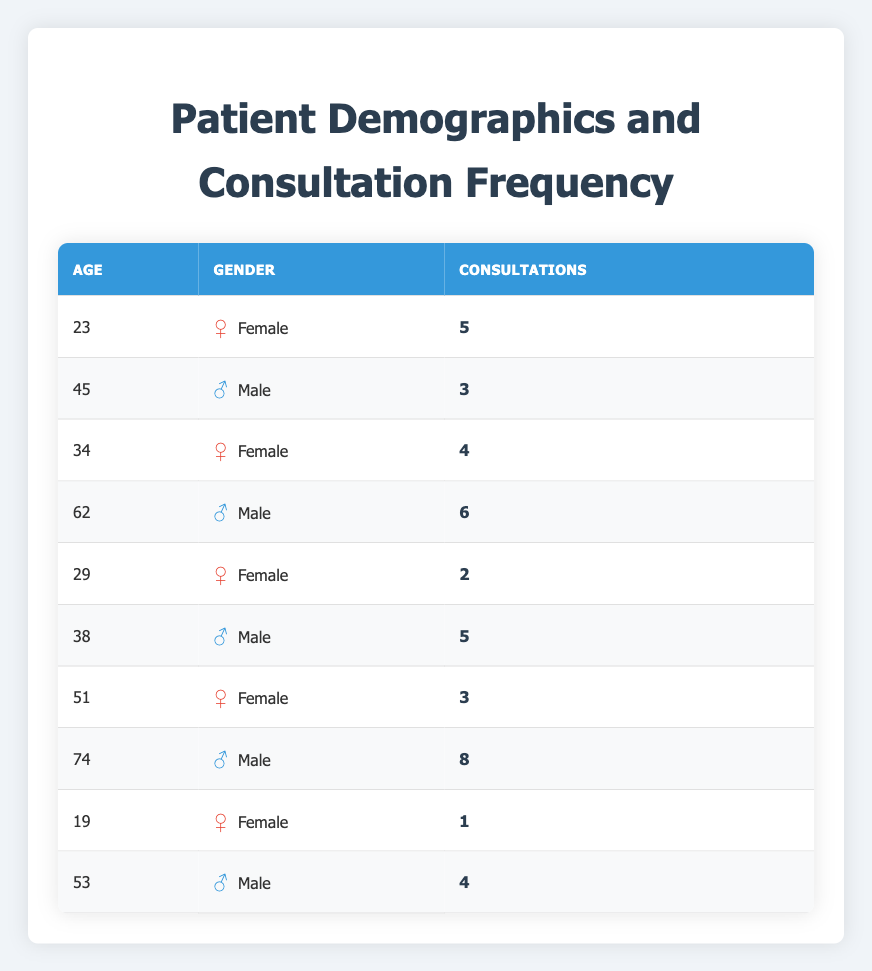What is the maximum number of consultations recorded for a patient? By reviewing the 'Consultations' column in the table, I can see that the highest value is 8, which corresponds to the patient aged 74.
Answer: 8 How many female patients have more than 3 consultations? I look at the 'Gender' column and filter for female patients. The only female patients with more than 3 consultations are aged 23 (5 consultations) and 34 (4 consultations). Therefore, there are 2 patients.
Answer: 2 What is the average age of male patients in the table? I identify the male patients in the table: 45, 62, 38, 74, and 53. I add their ages together (45 + 62 + 38 + 74 + 53) = 272. There are 5 male patients, so the average age is 272 / 5 = 54.4.
Answer: 54.4 Do all patients aged above 60 have a higher number of consultations than younger patients? The aged patients in the table above 60 are aged 62 (6 consultations) and 74 (8 consultations). The consultations of these patients are indeed higher than the patients aged 19 (1 consultation), 23 (5 consultations), 29 (2 consultations), and 34 (4 consultations). However, the 38-year-old male with 5 consultations also has a higher number than the 62-year-old. Thus, not all meet this criterion.
Answer: No What is the total number of consultations for all male patients? To find this, I sum the consultations of all male patients, which are 3 (45 years), 6 (62 years), 5 (38 years), 8 (74 years), and 4 (53 years). Thus, the total is calculated as 3 + 6 + 5 + 8 + 4 = 26.
Answer: 26 